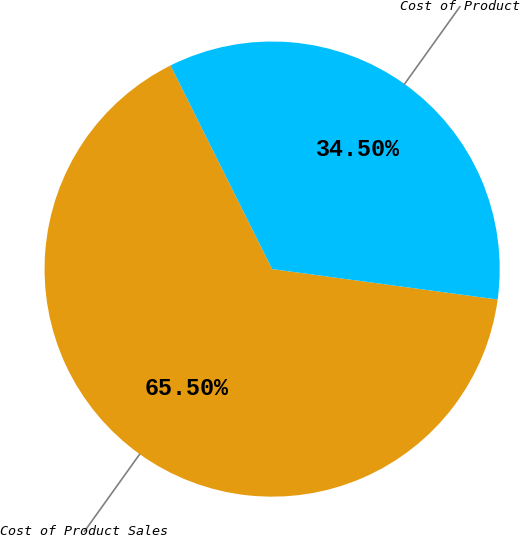Convert chart. <chart><loc_0><loc_0><loc_500><loc_500><pie_chart><fcel>Cost of Product Sales<fcel>Cost of Product<nl><fcel>65.5%<fcel>34.5%<nl></chart> 